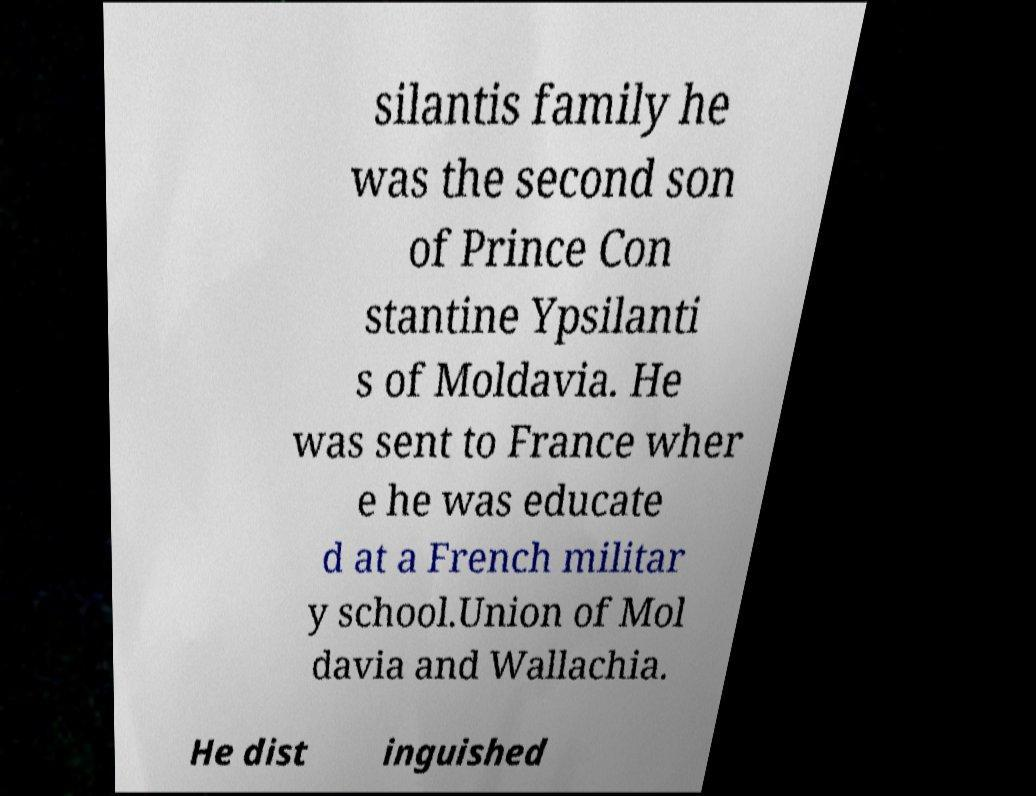There's text embedded in this image that I need extracted. Can you transcribe it verbatim? silantis family he was the second son of Prince Con stantine Ypsilanti s of Moldavia. He was sent to France wher e he was educate d at a French militar y school.Union of Mol davia and Wallachia. He dist inguished 